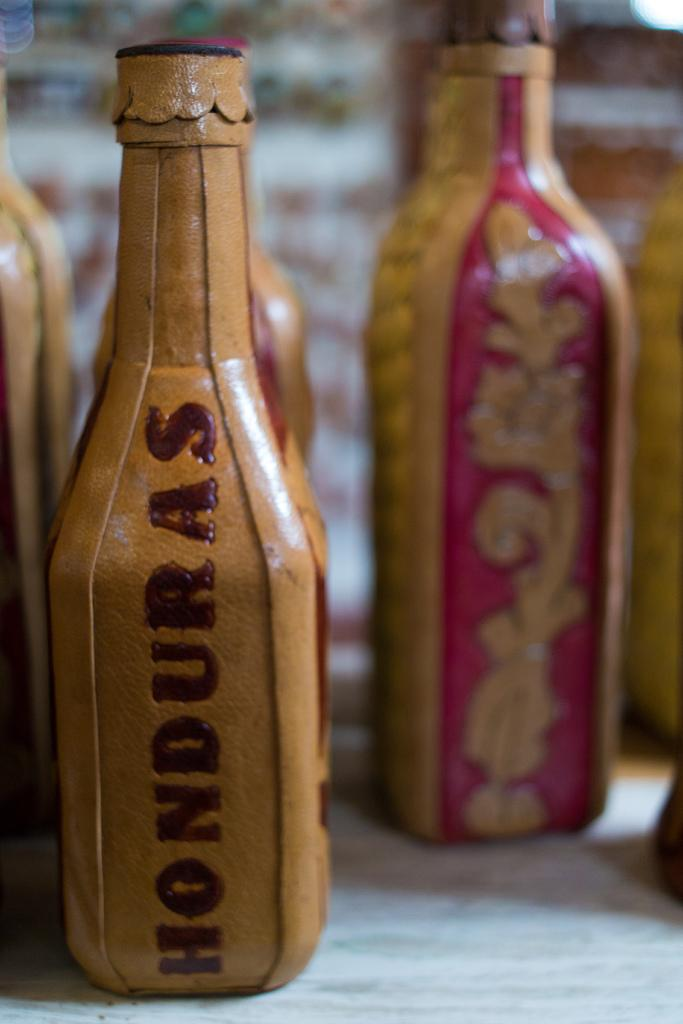<image>
Create a compact narrative representing the image presented. A bottle shaped from leather says Honduras on one side. 